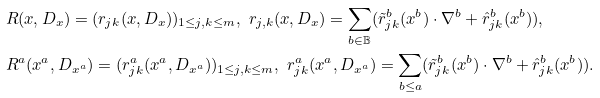Convert formula to latex. <formula><loc_0><loc_0><loc_500><loc_500>& R ( x , D _ { x } ) = ( r _ { j k } ( x , D _ { x } ) ) _ { 1 \leq j , k \leq m } , \ r _ { j , k } ( x , D _ { x } ) = \sum _ { b \in \mathbb { B } } ( \tilde { r } _ { j k } ^ { b } ( x ^ { b } ) \cdot \nabla ^ { b } + \hat { r } _ { j k } ^ { b } ( x ^ { b } ) ) , \\ & R ^ { a } ( x ^ { a } , D _ { x ^ { a } } ) = ( r ^ { a } _ { j k } ( x ^ { a } , D _ { x ^ { a } } ) ) _ { 1 \leq j , k \leq m } , \ r ^ { a } _ { j k } ( x ^ { a } , D _ { x ^ { a } } ) = \sum _ { b \leq a } ( \tilde { r } _ { j k } ^ { b } ( x ^ { b } ) \cdot \nabla ^ { b } + \hat { r } _ { j k } ^ { b } ( x ^ { b } ) ) .</formula> 